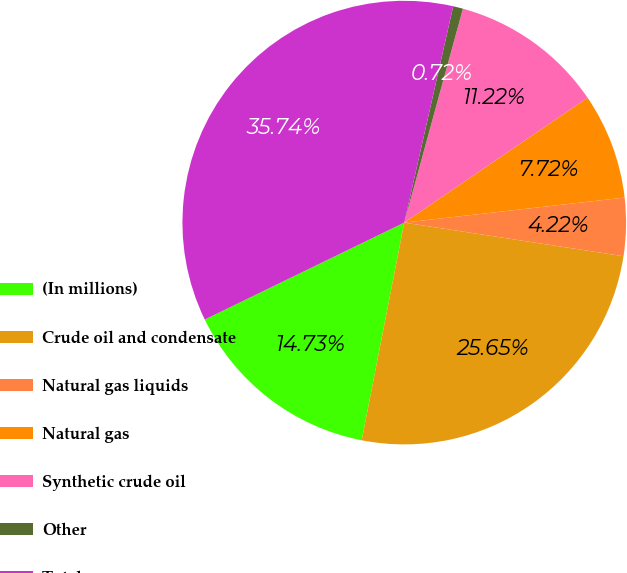Convert chart. <chart><loc_0><loc_0><loc_500><loc_500><pie_chart><fcel>(In millions)<fcel>Crude oil and condensate<fcel>Natural gas liquids<fcel>Natural gas<fcel>Synthetic crude oil<fcel>Other<fcel>Total revenues<nl><fcel>14.73%<fcel>25.65%<fcel>4.22%<fcel>7.72%<fcel>11.22%<fcel>0.72%<fcel>35.74%<nl></chart> 